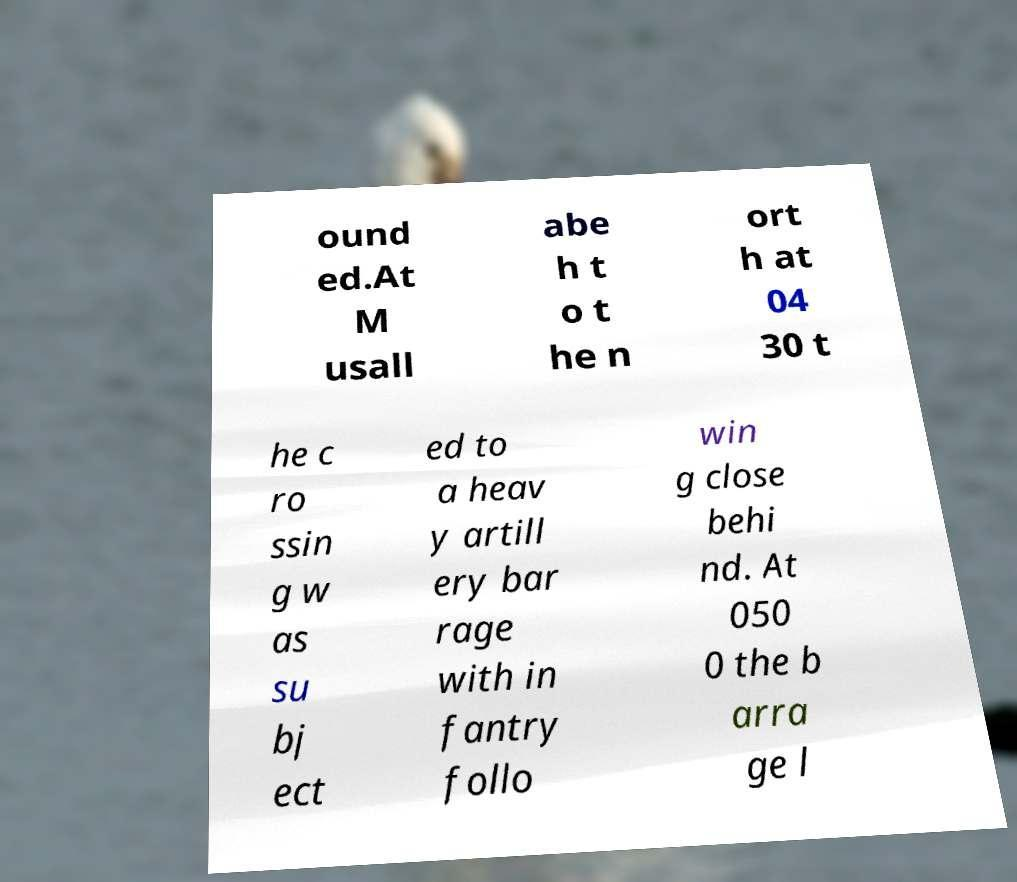For documentation purposes, I need the text within this image transcribed. Could you provide that? ound ed.At M usall abe h t o t he n ort h at 04 30 t he c ro ssin g w as su bj ect ed to a heav y artill ery bar rage with in fantry follo win g close behi nd. At 050 0 the b arra ge l 